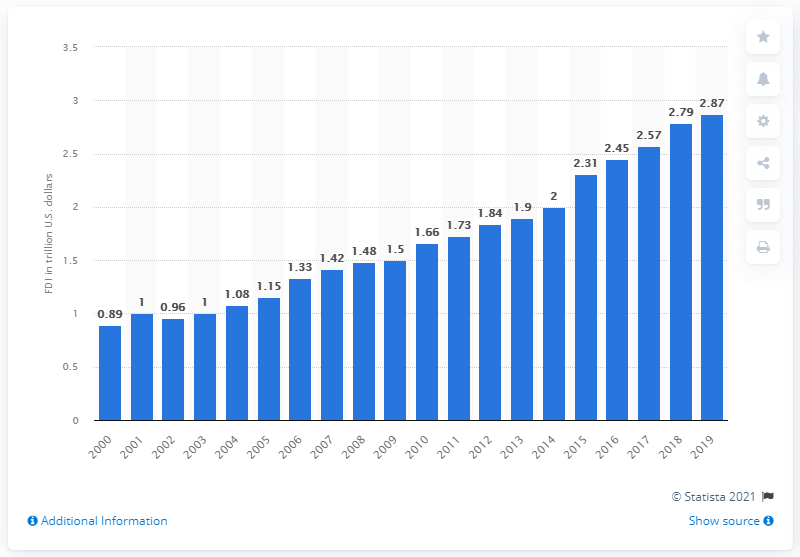Mention a couple of crucial points in this snapshot. The amount of European foreign direct investments in the United States in 2019 was 2.87. 